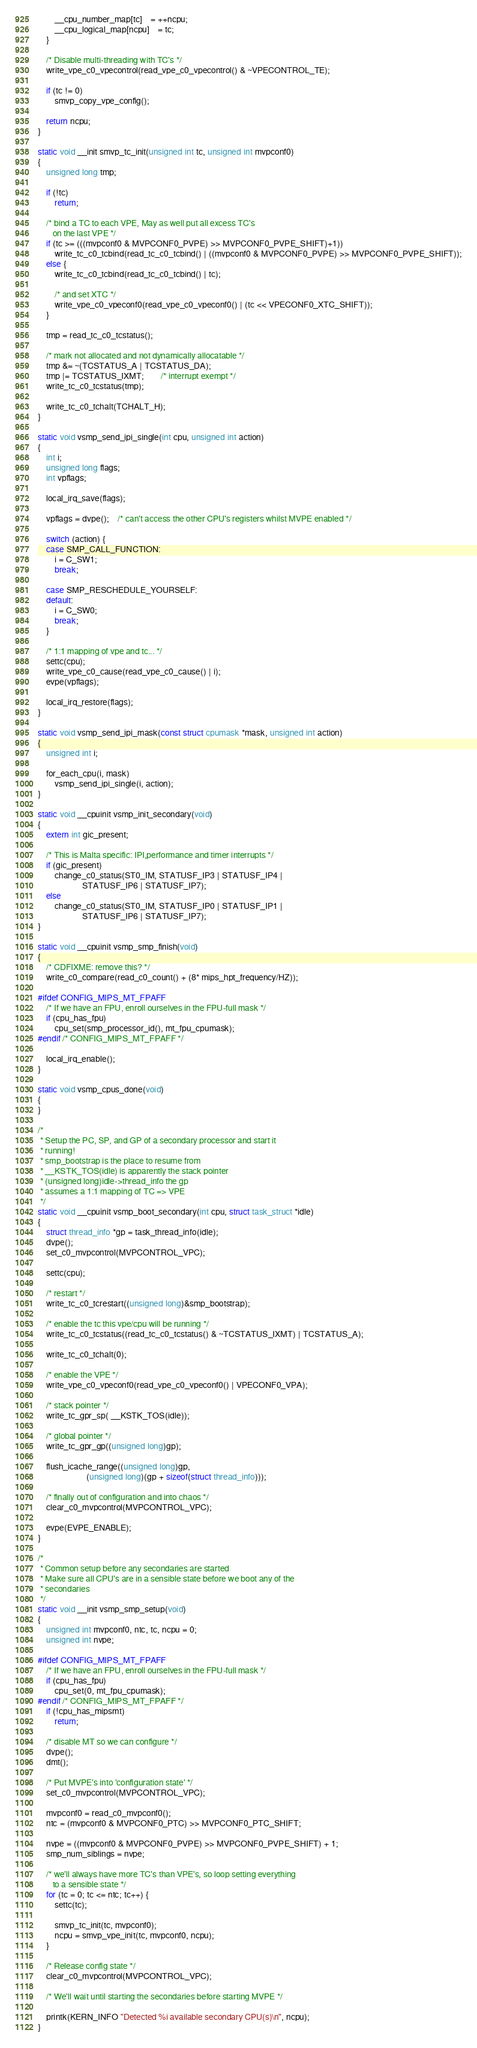<code> <loc_0><loc_0><loc_500><loc_500><_C_>		__cpu_number_map[tc]	= ++ncpu;
		__cpu_logical_map[ncpu]	= tc;
	}

	/* Disable multi-threading with TC's */
	write_vpe_c0_vpecontrol(read_vpe_c0_vpecontrol() & ~VPECONTROL_TE);

	if (tc != 0)
		smvp_copy_vpe_config();

	return ncpu;
}

static void __init smvp_tc_init(unsigned int tc, unsigned int mvpconf0)
{
	unsigned long tmp;

	if (!tc)
		return;

	/* bind a TC to each VPE, May as well put all excess TC's
	   on the last VPE */
	if (tc >= (((mvpconf0 & MVPCONF0_PVPE) >> MVPCONF0_PVPE_SHIFT)+1))
		write_tc_c0_tcbind(read_tc_c0_tcbind() | ((mvpconf0 & MVPCONF0_PVPE) >> MVPCONF0_PVPE_SHIFT));
	else {
		write_tc_c0_tcbind(read_tc_c0_tcbind() | tc);

		/* and set XTC */
		write_vpe_c0_vpeconf0(read_vpe_c0_vpeconf0() | (tc << VPECONF0_XTC_SHIFT));
	}

	tmp = read_tc_c0_tcstatus();

	/* mark not allocated and not dynamically allocatable */
	tmp &= ~(TCSTATUS_A | TCSTATUS_DA);
	tmp |= TCSTATUS_IXMT;		/* interrupt exempt */
	write_tc_c0_tcstatus(tmp);

	write_tc_c0_tchalt(TCHALT_H);
}

static void vsmp_send_ipi_single(int cpu, unsigned int action)
{
	int i;
	unsigned long flags;
	int vpflags;

	local_irq_save(flags);

	vpflags = dvpe();	/* can't access the other CPU's registers whilst MVPE enabled */

	switch (action) {
	case SMP_CALL_FUNCTION:
		i = C_SW1;
		break;

	case SMP_RESCHEDULE_YOURSELF:
	default:
		i = C_SW0;
		break;
	}

	/* 1:1 mapping of vpe and tc... */
	settc(cpu);
	write_vpe_c0_cause(read_vpe_c0_cause() | i);
	evpe(vpflags);

	local_irq_restore(flags);
}

static void vsmp_send_ipi_mask(const struct cpumask *mask, unsigned int action)
{
	unsigned int i;

	for_each_cpu(i, mask)
		vsmp_send_ipi_single(i, action);
}

static void __cpuinit vsmp_init_secondary(void)
{
	extern int gic_present;

	/* This is Malta specific: IPI,performance and timer interrupts */
	if (gic_present)
		change_c0_status(ST0_IM, STATUSF_IP3 | STATUSF_IP4 |
					 STATUSF_IP6 | STATUSF_IP7);
	else
		change_c0_status(ST0_IM, STATUSF_IP0 | STATUSF_IP1 |
					 STATUSF_IP6 | STATUSF_IP7);
}

static void __cpuinit vsmp_smp_finish(void)
{
	/* CDFIXME: remove this? */
	write_c0_compare(read_c0_count() + (8* mips_hpt_frequency/HZ));

#ifdef CONFIG_MIPS_MT_FPAFF
	/* If we have an FPU, enroll ourselves in the FPU-full mask */
	if (cpu_has_fpu)
		cpu_set(smp_processor_id(), mt_fpu_cpumask);
#endif /* CONFIG_MIPS_MT_FPAFF */

	local_irq_enable();
}

static void vsmp_cpus_done(void)
{
}

/*
 * Setup the PC, SP, and GP of a secondary processor and start it
 * running!
 * smp_bootstrap is the place to resume from
 * __KSTK_TOS(idle) is apparently the stack pointer
 * (unsigned long)idle->thread_info the gp
 * assumes a 1:1 mapping of TC => VPE
 */
static void __cpuinit vsmp_boot_secondary(int cpu, struct task_struct *idle)
{
	struct thread_info *gp = task_thread_info(idle);
	dvpe();
	set_c0_mvpcontrol(MVPCONTROL_VPC);

	settc(cpu);

	/* restart */
	write_tc_c0_tcrestart((unsigned long)&smp_bootstrap);

	/* enable the tc this vpe/cpu will be running */
	write_tc_c0_tcstatus((read_tc_c0_tcstatus() & ~TCSTATUS_IXMT) | TCSTATUS_A);

	write_tc_c0_tchalt(0);

	/* enable the VPE */
	write_vpe_c0_vpeconf0(read_vpe_c0_vpeconf0() | VPECONF0_VPA);

	/* stack pointer */
	write_tc_gpr_sp( __KSTK_TOS(idle));

	/* global pointer */
	write_tc_gpr_gp((unsigned long)gp);

	flush_icache_range((unsigned long)gp,
	                   (unsigned long)(gp + sizeof(struct thread_info)));

	/* finally out of configuration and into chaos */
	clear_c0_mvpcontrol(MVPCONTROL_VPC);

	evpe(EVPE_ENABLE);
}

/*
 * Common setup before any secondaries are started
 * Make sure all CPU's are in a sensible state before we boot any of the
 * secondaries
 */
static void __init vsmp_smp_setup(void)
{
	unsigned int mvpconf0, ntc, tc, ncpu = 0;
	unsigned int nvpe;

#ifdef CONFIG_MIPS_MT_FPAFF
	/* If we have an FPU, enroll ourselves in the FPU-full mask */
	if (cpu_has_fpu)
		cpu_set(0, mt_fpu_cpumask);
#endif /* CONFIG_MIPS_MT_FPAFF */
	if (!cpu_has_mipsmt)
		return;

	/* disable MT so we can configure */
	dvpe();
	dmt();

	/* Put MVPE's into 'configuration state' */
	set_c0_mvpcontrol(MVPCONTROL_VPC);

	mvpconf0 = read_c0_mvpconf0();
	ntc = (mvpconf0 & MVPCONF0_PTC) >> MVPCONF0_PTC_SHIFT;

	nvpe = ((mvpconf0 & MVPCONF0_PVPE) >> MVPCONF0_PVPE_SHIFT) + 1;
	smp_num_siblings = nvpe;

	/* we'll always have more TC's than VPE's, so loop setting everything
	   to a sensible state */
	for (tc = 0; tc <= ntc; tc++) {
		settc(tc);

		smvp_tc_init(tc, mvpconf0);
		ncpu = smvp_vpe_init(tc, mvpconf0, ncpu);
	}

	/* Release config state */
	clear_c0_mvpcontrol(MVPCONTROL_VPC);

	/* We'll wait until starting the secondaries before starting MVPE */

	printk(KERN_INFO "Detected %i available secondary CPU(s)\n", ncpu);
}
</code> 